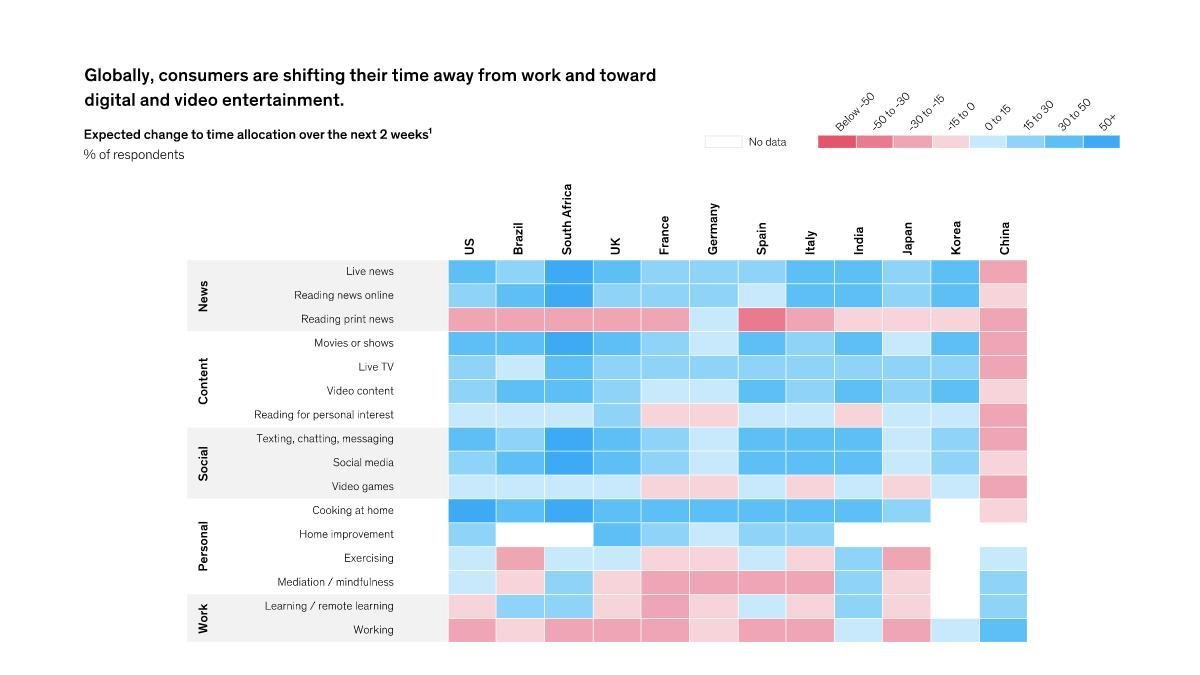What is the expected change in time allocation by people of UK for home improvement - increase or decrease?
Answer the question with a short phrase. increase What is the expected change in time allocation by people of France for live news- increase or decrease? increase What is the expected change in time allocation (in percentage) by people of Italy for reading news online? 30 to 50 What is the expected change in time allocation (in percentage) by people of South Africa for cooking at home? 50+ What is the expected change in time allocation (in percentage) by people of India for watching live news? 30 to 50 What is the expected change in time allocation by people of India for home improvement - increase or decrease? decrease What is the expected change in time allocation by people of Japan for social media - increase or decrease? increase What is the expected change in time allocation (in percentage) by people of South Africa for watching live news? above 50 What is the expected change in time allocation by people of Brazil for exercising - increase or decrease? decrease What is the expected change in time allocation (in percentage) by people of Germany for meditation/mindfulness? -30 to -15 What is the expected change in time allocation by people of India for working- increase or decrease? increase What is the expected change in time allocation by people of China for live TV - increase or decrease? decrease What is the expected change in time allocation (in percentage) by people of Spain for exercising? 0 to 15 What is the expected change in time allocation (in percentage) by people of Brazil for social media? 30 to 50 What is the expected change in time allocation (in percentage) by people of Germany for exercising? -15 to 0 